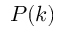Convert formula to latex. <formula><loc_0><loc_0><loc_500><loc_500>P ( k )</formula> 